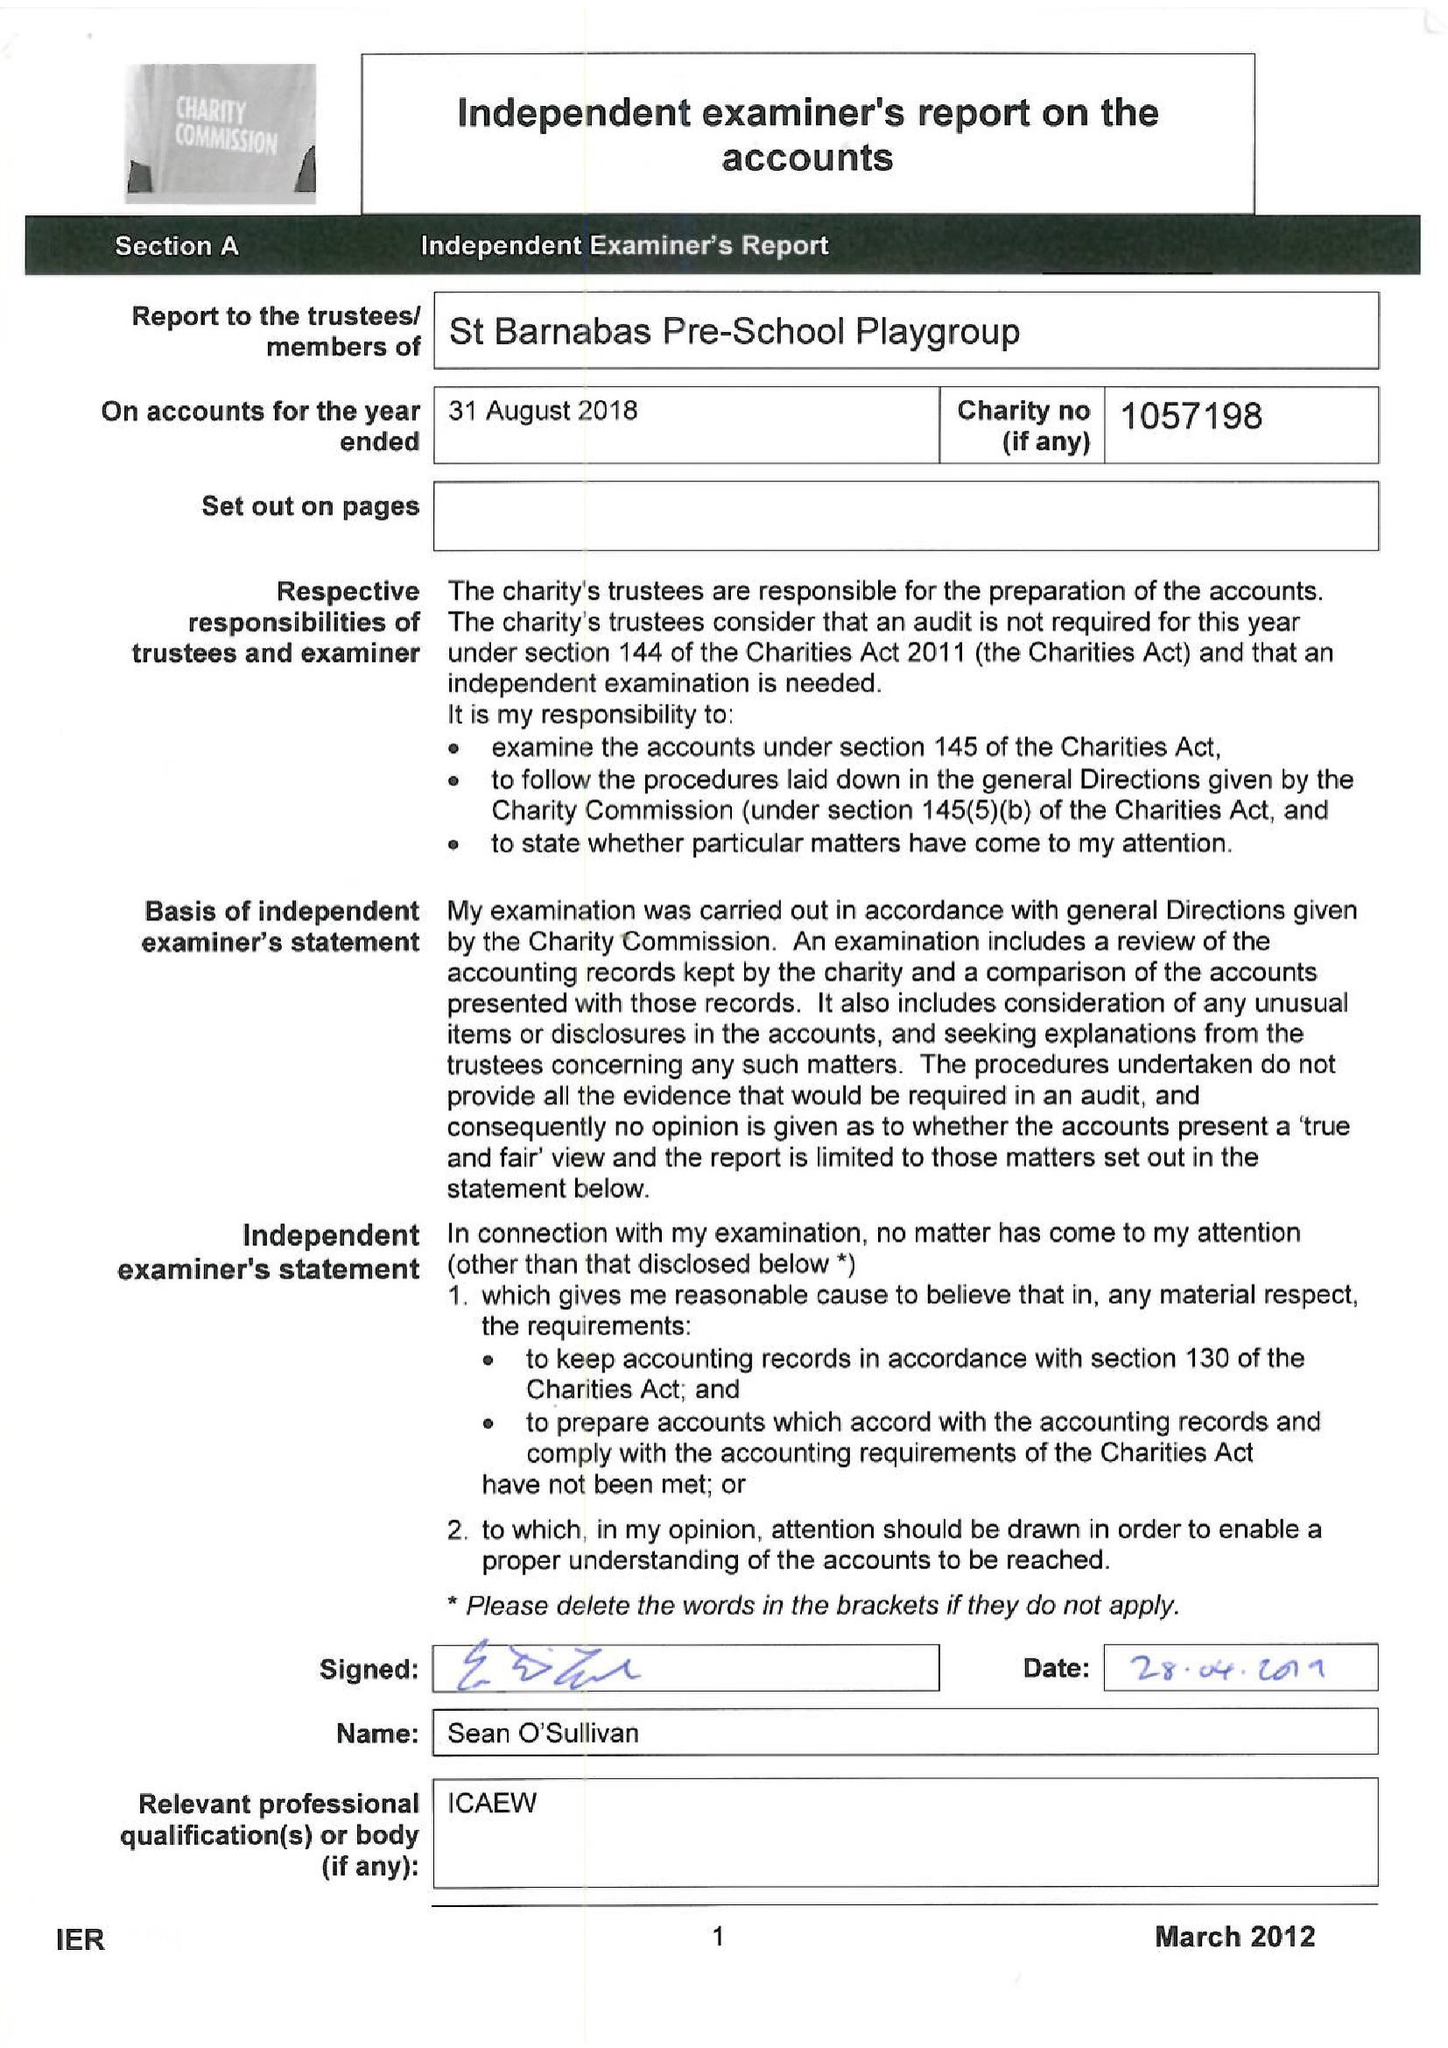What is the value for the spending_annually_in_british_pounds?
Answer the question using a single word or phrase. 60093.00 